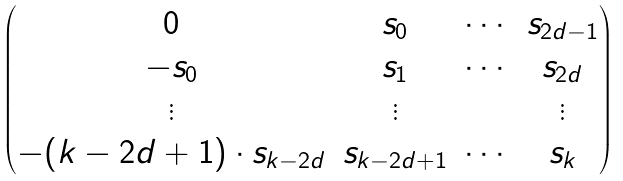<formula> <loc_0><loc_0><loc_500><loc_500>\begin{pmatrix} 0 & s _ { 0 } & \cdots & s _ { 2 d - 1 } \\ - s _ { 0 } & s _ { 1 } & \cdots & s _ { 2 d } \\ \vdots & \vdots & & \vdots \\ - ( k - 2 d + 1 ) \cdot s _ { k - 2 d } & s _ { k - 2 d + 1 } & \cdots & s _ { k } \end{pmatrix}</formula> 